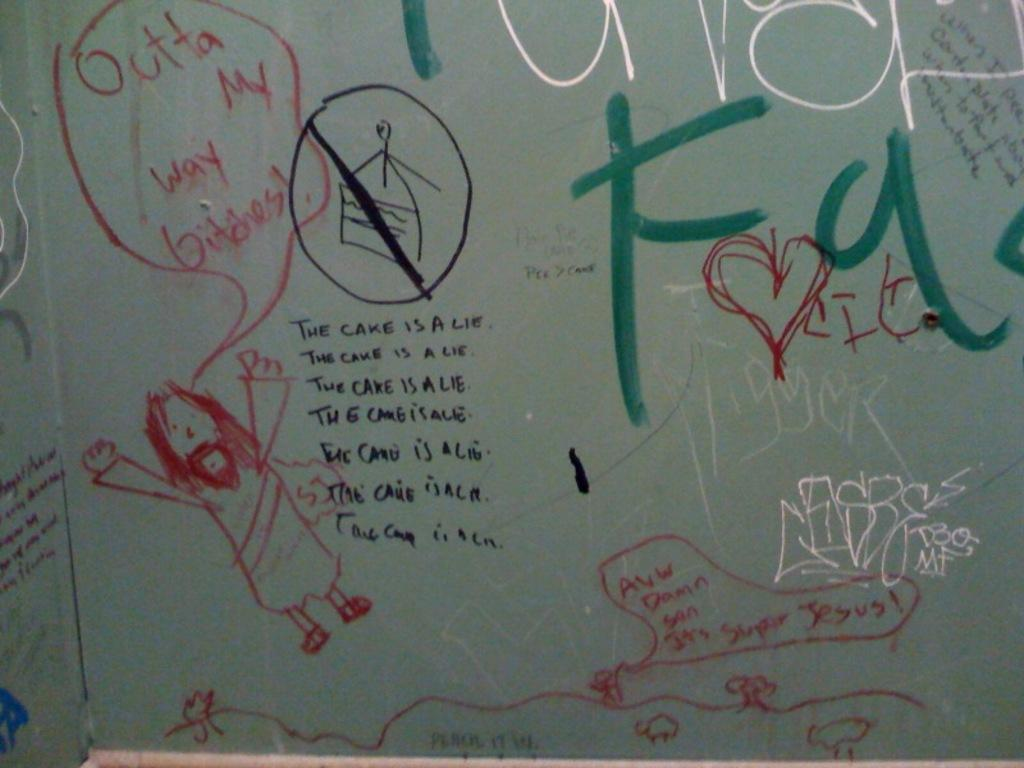<image>
Render a clear and concise summary of the photo. Drawing of a man who is saying "Outta my way bitches". 